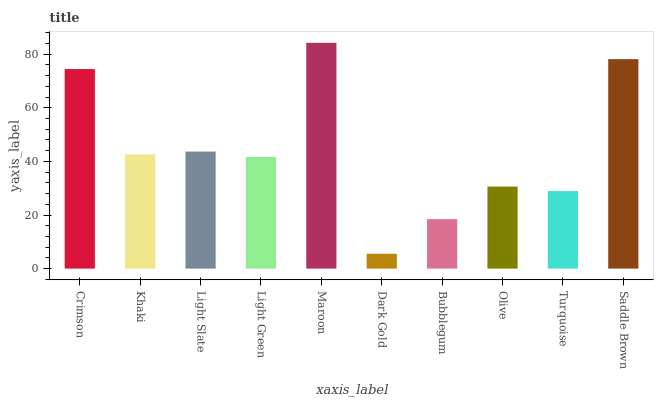Is Dark Gold the minimum?
Answer yes or no. Yes. Is Maroon the maximum?
Answer yes or no. Yes. Is Khaki the minimum?
Answer yes or no. No. Is Khaki the maximum?
Answer yes or no. No. Is Crimson greater than Khaki?
Answer yes or no. Yes. Is Khaki less than Crimson?
Answer yes or no. Yes. Is Khaki greater than Crimson?
Answer yes or no. No. Is Crimson less than Khaki?
Answer yes or no. No. Is Khaki the high median?
Answer yes or no. Yes. Is Light Green the low median?
Answer yes or no. Yes. Is Bubblegum the high median?
Answer yes or no. No. Is Dark Gold the low median?
Answer yes or no. No. 